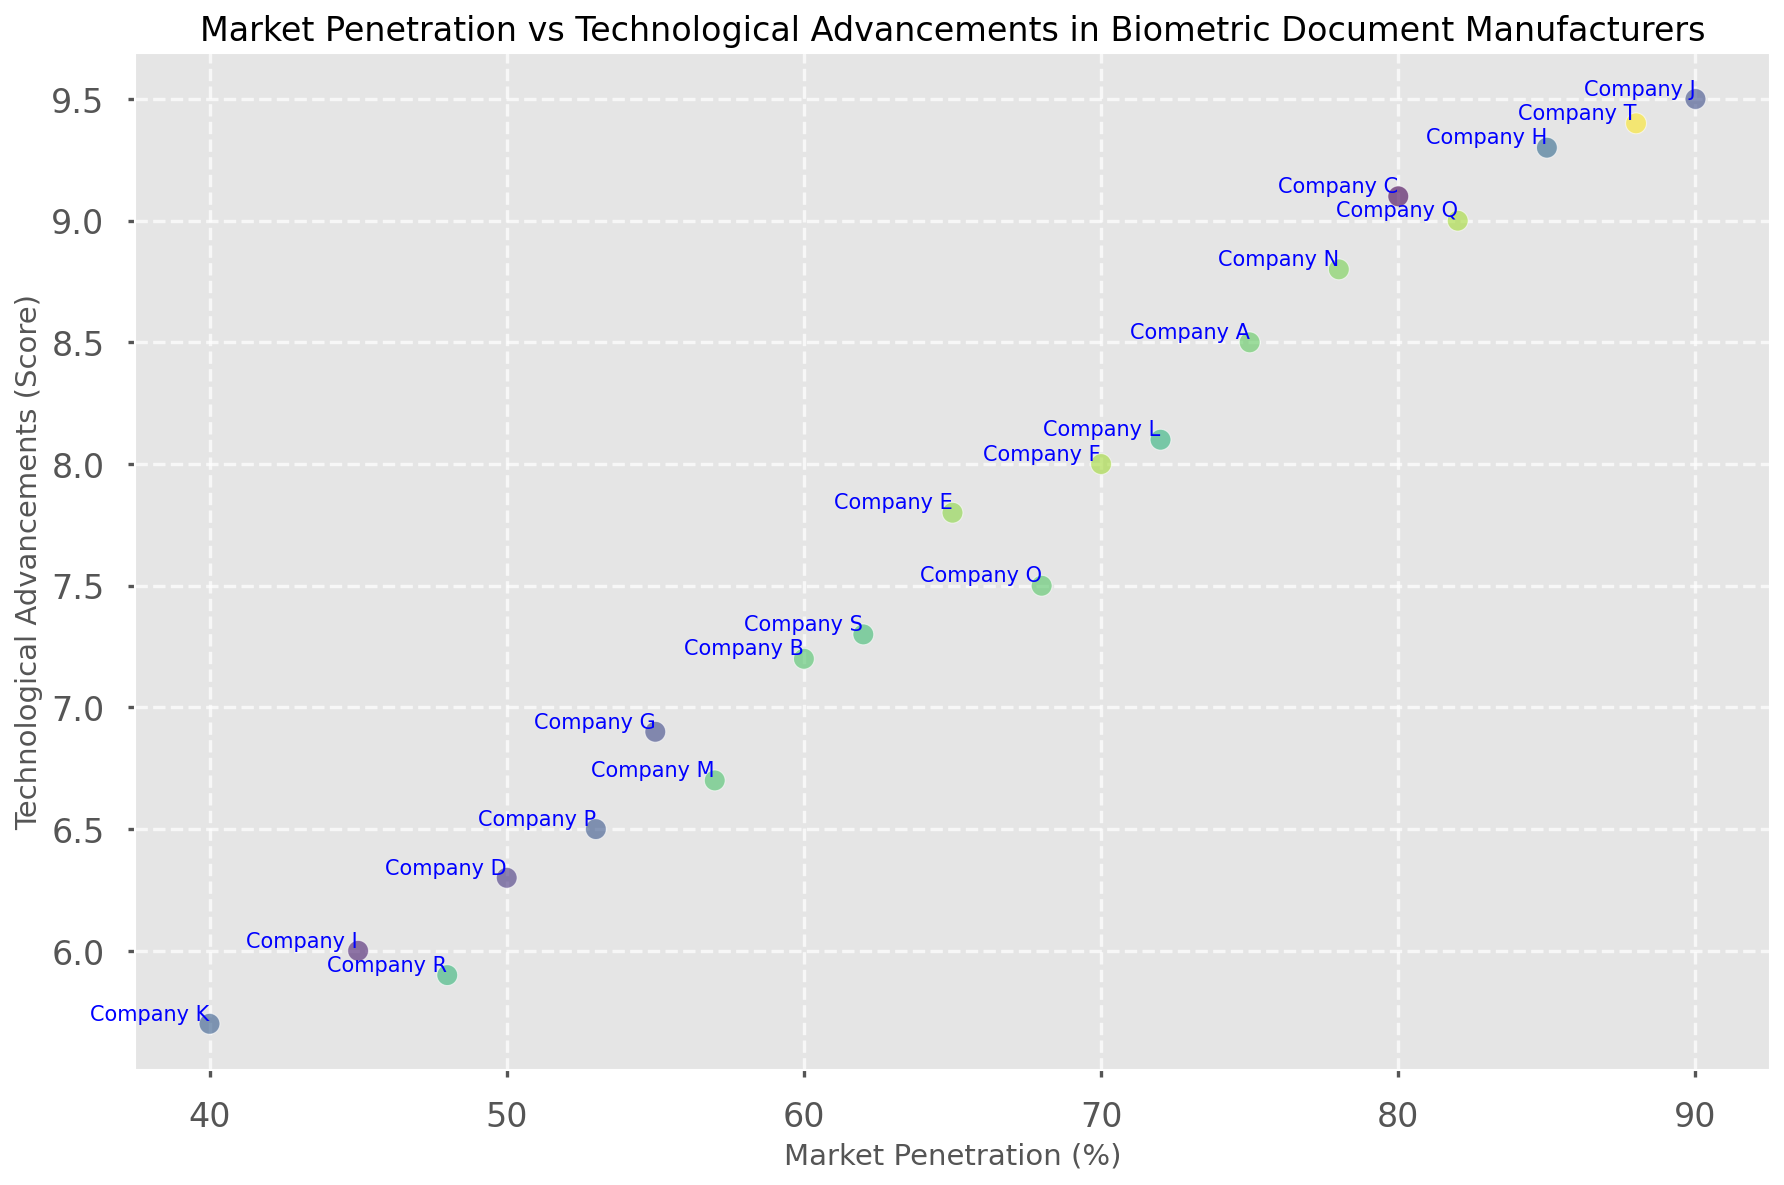Which company has the highest market penetration? By observing the plot, Company J has the highest marker on the x-axis for Market Penetration (%).
Answer: Company J Which company has the lowest technological advancements score? By looking at the plot, Company K has the lowest point on the y-axis for Technological Advancements (Score).
Answer: Company K Between Company A and Company C, which has a higher technological advancements score and by how much? Company C has a Technological Advancements score of 9.1, and Company A has a score of 8.5. So, the difference is 9.1 - 8.5.
Answer: Company C, 0.6 What is the mean market penetration of companies with a technological advancements score above 9.0? Companies with technological advancements score above 9.0 are Company C, Company H, Company J, Company Q, and Company T. Their market penetrations are 80, 85, 90, 82, and 88, respectively. The mean is (80 + 85 + 90 + 82 + 88) / 5.
Answer: 85 Which companies have both market penetration and technological advancements above 70% and 8.0, respectively? By identifying companies with Market Penetration (%) > 70 and Technological Advancements (Score) > 8.0 from the plot, we find companies H, J, Q, and T.
Answer: Company H, Company J, Company Q, Company T How does the market penetration of Company F compare to Company O? Company F has a market penetration of 70%, while Company O has a market penetration of 68%. So, Company F has a higher market penetration by 2.
Answer: Company F is higher by 2% Is there a visible correlation between market penetration and technological advancements? By observing the plot, there seems to be a positive correlation where companies with higher technological advancements usually have higher market penetration.
Answer: Yes On average, do companies with market penetration above 75% have higher technological advancement scores than those below 75%? Identifying companies with market penetration above 75%: A, C, H, J, Q, T. Their scores: 8.5, 9.1, 9.3, 9.5, 9.0, 9.4 (average: (8.5 + 9.1 + 9.3 + 9.5 + 9.0 + 9.4) / 6 = 9.13). For below 75%: B, D, E, F, G, I, K, L, M, N, O, P, R, S (average: (7.2 + 6.3 + 7.8 + 8 + 6.9 + 6 + 5.7 + 8.1 + 6.7 + 8.8 + 7.5 + 6.5 + 5.9 + 7.3) / 14 = 6.98).
Answer: Yes, 9.13 vs. 6.98 